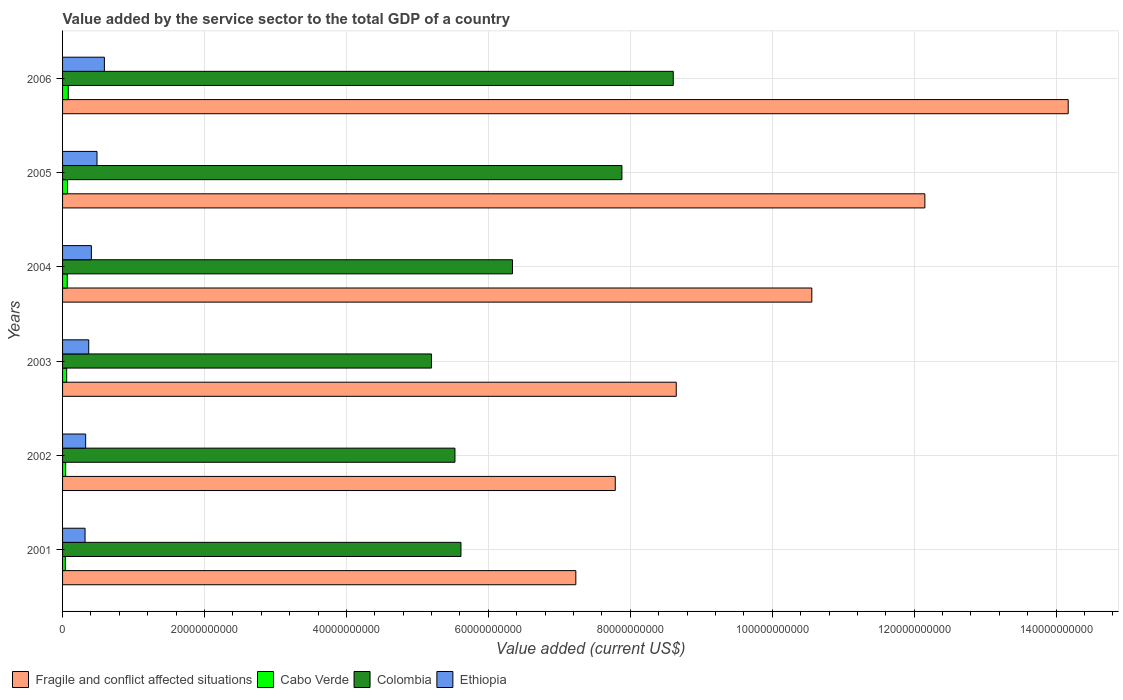Are the number of bars per tick equal to the number of legend labels?
Keep it short and to the point. Yes. Are the number of bars on each tick of the Y-axis equal?
Give a very brief answer. Yes. What is the label of the 2nd group of bars from the top?
Your answer should be very brief. 2005. In how many cases, is the number of bars for a given year not equal to the number of legend labels?
Provide a short and direct response. 0. What is the value added by the service sector to the total GDP in Cabo Verde in 2003?
Offer a very short reply. 5.81e+08. Across all years, what is the maximum value added by the service sector to the total GDP in Cabo Verde?
Your answer should be very brief. 8.04e+08. Across all years, what is the minimum value added by the service sector to the total GDP in Colombia?
Make the answer very short. 5.20e+1. In which year was the value added by the service sector to the total GDP in Colombia minimum?
Ensure brevity in your answer.  2003. What is the total value added by the service sector to the total GDP in Ethiopia in the graph?
Offer a very short reply. 2.49e+1. What is the difference between the value added by the service sector to the total GDP in Fragile and conflict affected situations in 2003 and that in 2004?
Keep it short and to the point. -1.91e+1. What is the difference between the value added by the service sector to the total GDP in Colombia in 2004 and the value added by the service sector to the total GDP in Fragile and conflict affected situations in 2003?
Make the answer very short. -2.31e+1. What is the average value added by the service sector to the total GDP in Colombia per year?
Your answer should be very brief. 6.53e+1. In the year 2001, what is the difference between the value added by the service sector to the total GDP in Fragile and conflict affected situations and value added by the service sector to the total GDP in Colombia?
Make the answer very short. 1.62e+1. What is the ratio of the value added by the service sector to the total GDP in Cabo Verde in 2003 to that in 2005?
Offer a terse response. 0.83. Is the difference between the value added by the service sector to the total GDP in Fragile and conflict affected situations in 2001 and 2005 greater than the difference between the value added by the service sector to the total GDP in Colombia in 2001 and 2005?
Your response must be concise. No. What is the difference between the highest and the second highest value added by the service sector to the total GDP in Ethiopia?
Keep it short and to the point. 1.04e+09. What is the difference between the highest and the lowest value added by the service sector to the total GDP in Ethiopia?
Provide a succinct answer. 2.73e+09. What does the 4th bar from the top in 2001 represents?
Keep it short and to the point. Fragile and conflict affected situations. What does the 4th bar from the bottom in 2001 represents?
Make the answer very short. Ethiopia. How many bars are there?
Offer a terse response. 24. How many years are there in the graph?
Your response must be concise. 6. Are the values on the major ticks of X-axis written in scientific E-notation?
Offer a terse response. No. What is the title of the graph?
Make the answer very short. Value added by the service sector to the total GDP of a country. What is the label or title of the X-axis?
Your answer should be compact. Value added (current US$). What is the Value added (current US$) of Fragile and conflict affected situations in 2001?
Your response must be concise. 7.23e+1. What is the Value added (current US$) of Cabo Verde in 2001?
Your response must be concise. 3.91e+08. What is the Value added (current US$) of Colombia in 2001?
Your response must be concise. 5.61e+1. What is the Value added (current US$) in Ethiopia in 2001?
Keep it short and to the point. 3.17e+09. What is the Value added (current US$) in Fragile and conflict affected situations in 2002?
Give a very brief answer. 7.79e+1. What is the Value added (current US$) of Cabo Verde in 2002?
Your answer should be very brief. 4.38e+08. What is the Value added (current US$) of Colombia in 2002?
Your answer should be very brief. 5.53e+1. What is the Value added (current US$) in Ethiopia in 2002?
Keep it short and to the point. 3.25e+09. What is the Value added (current US$) in Fragile and conflict affected situations in 2003?
Give a very brief answer. 8.65e+1. What is the Value added (current US$) in Cabo Verde in 2003?
Keep it short and to the point. 5.81e+08. What is the Value added (current US$) in Colombia in 2003?
Give a very brief answer. 5.20e+1. What is the Value added (current US$) in Ethiopia in 2003?
Your answer should be very brief. 3.69e+09. What is the Value added (current US$) of Fragile and conflict affected situations in 2004?
Your response must be concise. 1.06e+11. What is the Value added (current US$) of Cabo Verde in 2004?
Your answer should be very brief. 6.65e+08. What is the Value added (current US$) in Colombia in 2004?
Your answer should be very brief. 6.34e+1. What is the Value added (current US$) of Ethiopia in 2004?
Offer a terse response. 4.06e+09. What is the Value added (current US$) in Fragile and conflict affected situations in 2005?
Give a very brief answer. 1.22e+11. What is the Value added (current US$) in Cabo Verde in 2005?
Your answer should be very brief. 6.98e+08. What is the Value added (current US$) of Colombia in 2005?
Ensure brevity in your answer.  7.88e+1. What is the Value added (current US$) of Ethiopia in 2005?
Keep it short and to the point. 4.85e+09. What is the Value added (current US$) in Fragile and conflict affected situations in 2006?
Your response must be concise. 1.42e+11. What is the Value added (current US$) in Cabo Verde in 2006?
Your answer should be very brief. 8.04e+08. What is the Value added (current US$) of Colombia in 2006?
Offer a very short reply. 8.61e+1. What is the Value added (current US$) of Ethiopia in 2006?
Make the answer very short. 5.89e+09. Across all years, what is the maximum Value added (current US$) in Fragile and conflict affected situations?
Ensure brevity in your answer.  1.42e+11. Across all years, what is the maximum Value added (current US$) in Cabo Verde?
Offer a terse response. 8.04e+08. Across all years, what is the maximum Value added (current US$) in Colombia?
Your answer should be very brief. 8.61e+1. Across all years, what is the maximum Value added (current US$) of Ethiopia?
Your response must be concise. 5.89e+09. Across all years, what is the minimum Value added (current US$) in Fragile and conflict affected situations?
Your answer should be very brief. 7.23e+1. Across all years, what is the minimum Value added (current US$) of Cabo Verde?
Offer a very short reply. 3.91e+08. Across all years, what is the minimum Value added (current US$) of Colombia?
Offer a very short reply. 5.20e+1. Across all years, what is the minimum Value added (current US$) in Ethiopia?
Keep it short and to the point. 3.17e+09. What is the total Value added (current US$) of Fragile and conflict affected situations in the graph?
Offer a terse response. 6.05e+11. What is the total Value added (current US$) in Cabo Verde in the graph?
Provide a short and direct response. 3.58e+09. What is the total Value added (current US$) of Colombia in the graph?
Provide a short and direct response. 3.92e+11. What is the total Value added (current US$) in Ethiopia in the graph?
Provide a succinct answer. 2.49e+1. What is the difference between the Value added (current US$) in Fragile and conflict affected situations in 2001 and that in 2002?
Make the answer very short. -5.56e+09. What is the difference between the Value added (current US$) in Cabo Verde in 2001 and that in 2002?
Ensure brevity in your answer.  -4.75e+07. What is the difference between the Value added (current US$) of Colombia in 2001 and that in 2002?
Your answer should be compact. 8.46e+08. What is the difference between the Value added (current US$) of Ethiopia in 2001 and that in 2002?
Your response must be concise. -8.46e+07. What is the difference between the Value added (current US$) of Fragile and conflict affected situations in 2001 and that in 2003?
Ensure brevity in your answer.  -1.41e+1. What is the difference between the Value added (current US$) in Cabo Verde in 2001 and that in 2003?
Your answer should be very brief. -1.90e+08. What is the difference between the Value added (current US$) in Colombia in 2001 and that in 2003?
Keep it short and to the point. 4.15e+09. What is the difference between the Value added (current US$) of Ethiopia in 2001 and that in 2003?
Your answer should be very brief. -5.18e+08. What is the difference between the Value added (current US$) in Fragile and conflict affected situations in 2001 and that in 2004?
Offer a terse response. -3.33e+1. What is the difference between the Value added (current US$) of Cabo Verde in 2001 and that in 2004?
Provide a short and direct response. -2.74e+08. What is the difference between the Value added (current US$) of Colombia in 2001 and that in 2004?
Offer a terse response. -7.26e+09. What is the difference between the Value added (current US$) of Ethiopia in 2001 and that in 2004?
Your response must be concise. -8.91e+08. What is the difference between the Value added (current US$) in Fragile and conflict affected situations in 2001 and that in 2005?
Provide a short and direct response. -4.92e+1. What is the difference between the Value added (current US$) of Cabo Verde in 2001 and that in 2005?
Your answer should be compact. -3.07e+08. What is the difference between the Value added (current US$) in Colombia in 2001 and that in 2005?
Keep it short and to the point. -2.27e+1. What is the difference between the Value added (current US$) in Ethiopia in 2001 and that in 2005?
Make the answer very short. -1.69e+09. What is the difference between the Value added (current US$) of Fragile and conflict affected situations in 2001 and that in 2006?
Offer a very short reply. -6.94e+1. What is the difference between the Value added (current US$) of Cabo Verde in 2001 and that in 2006?
Your answer should be compact. -4.13e+08. What is the difference between the Value added (current US$) of Colombia in 2001 and that in 2006?
Provide a succinct answer. -2.99e+1. What is the difference between the Value added (current US$) in Ethiopia in 2001 and that in 2006?
Ensure brevity in your answer.  -2.73e+09. What is the difference between the Value added (current US$) in Fragile and conflict affected situations in 2002 and that in 2003?
Your response must be concise. -8.59e+09. What is the difference between the Value added (current US$) of Cabo Verde in 2002 and that in 2003?
Make the answer very short. -1.42e+08. What is the difference between the Value added (current US$) in Colombia in 2002 and that in 2003?
Keep it short and to the point. 3.31e+09. What is the difference between the Value added (current US$) of Ethiopia in 2002 and that in 2003?
Ensure brevity in your answer.  -4.33e+08. What is the difference between the Value added (current US$) of Fragile and conflict affected situations in 2002 and that in 2004?
Ensure brevity in your answer.  -2.77e+1. What is the difference between the Value added (current US$) of Cabo Verde in 2002 and that in 2004?
Provide a succinct answer. -2.26e+08. What is the difference between the Value added (current US$) in Colombia in 2002 and that in 2004?
Provide a succinct answer. -8.11e+09. What is the difference between the Value added (current US$) of Ethiopia in 2002 and that in 2004?
Give a very brief answer. -8.06e+08. What is the difference between the Value added (current US$) in Fragile and conflict affected situations in 2002 and that in 2005?
Your response must be concise. -4.36e+1. What is the difference between the Value added (current US$) in Cabo Verde in 2002 and that in 2005?
Your answer should be compact. -2.59e+08. What is the difference between the Value added (current US$) in Colombia in 2002 and that in 2005?
Keep it short and to the point. -2.35e+1. What is the difference between the Value added (current US$) in Ethiopia in 2002 and that in 2005?
Your response must be concise. -1.60e+09. What is the difference between the Value added (current US$) in Fragile and conflict affected situations in 2002 and that in 2006?
Offer a terse response. -6.38e+1. What is the difference between the Value added (current US$) in Cabo Verde in 2002 and that in 2006?
Give a very brief answer. -3.66e+08. What is the difference between the Value added (current US$) in Colombia in 2002 and that in 2006?
Give a very brief answer. -3.08e+1. What is the difference between the Value added (current US$) in Ethiopia in 2002 and that in 2006?
Ensure brevity in your answer.  -2.64e+09. What is the difference between the Value added (current US$) in Fragile and conflict affected situations in 2003 and that in 2004?
Provide a short and direct response. -1.91e+1. What is the difference between the Value added (current US$) in Cabo Verde in 2003 and that in 2004?
Keep it short and to the point. -8.42e+07. What is the difference between the Value added (current US$) in Colombia in 2003 and that in 2004?
Your response must be concise. -1.14e+1. What is the difference between the Value added (current US$) in Ethiopia in 2003 and that in 2004?
Make the answer very short. -3.73e+08. What is the difference between the Value added (current US$) of Fragile and conflict affected situations in 2003 and that in 2005?
Offer a very short reply. -3.50e+1. What is the difference between the Value added (current US$) of Cabo Verde in 2003 and that in 2005?
Ensure brevity in your answer.  -1.17e+08. What is the difference between the Value added (current US$) of Colombia in 2003 and that in 2005?
Make the answer very short. -2.68e+1. What is the difference between the Value added (current US$) of Ethiopia in 2003 and that in 2005?
Ensure brevity in your answer.  -1.17e+09. What is the difference between the Value added (current US$) of Fragile and conflict affected situations in 2003 and that in 2006?
Provide a short and direct response. -5.52e+1. What is the difference between the Value added (current US$) of Cabo Verde in 2003 and that in 2006?
Offer a very short reply. -2.24e+08. What is the difference between the Value added (current US$) of Colombia in 2003 and that in 2006?
Your response must be concise. -3.41e+1. What is the difference between the Value added (current US$) in Ethiopia in 2003 and that in 2006?
Make the answer very short. -2.21e+09. What is the difference between the Value added (current US$) of Fragile and conflict affected situations in 2004 and that in 2005?
Your answer should be compact. -1.59e+1. What is the difference between the Value added (current US$) of Cabo Verde in 2004 and that in 2005?
Provide a succinct answer. -3.30e+07. What is the difference between the Value added (current US$) in Colombia in 2004 and that in 2005?
Your answer should be very brief. -1.54e+1. What is the difference between the Value added (current US$) in Ethiopia in 2004 and that in 2005?
Provide a succinct answer. -7.94e+08. What is the difference between the Value added (current US$) in Fragile and conflict affected situations in 2004 and that in 2006?
Ensure brevity in your answer.  -3.61e+1. What is the difference between the Value added (current US$) in Cabo Verde in 2004 and that in 2006?
Make the answer very short. -1.39e+08. What is the difference between the Value added (current US$) of Colombia in 2004 and that in 2006?
Provide a short and direct response. -2.27e+1. What is the difference between the Value added (current US$) in Ethiopia in 2004 and that in 2006?
Give a very brief answer. -1.83e+09. What is the difference between the Value added (current US$) of Fragile and conflict affected situations in 2005 and that in 2006?
Offer a terse response. -2.02e+1. What is the difference between the Value added (current US$) of Cabo Verde in 2005 and that in 2006?
Offer a very short reply. -1.06e+08. What is the difference between the Value added (current US$) in Colombia in 2005 and that in 2006?
Your answer should be compact. -7.23e+09. What is the difference between the Value added (current US$) of Ethiopia in 2005 and that in 2006?
Offer a terse response. -1.04e+09. What is the difference between the Value added (current US$) of Fragile and conflict affected situations in 2001 and the Value added (current US$) of Cabo Verde in 2002?
Ensure brevity in your answer.  7.19e+1. What is the difference between the Value added (current US$) in Fragile and conflict affected situations in 2001 and the Value added (current US$) in Colombia in 2002?
Your answer should be compact. 1.70e+1. What is the difference between the Value added (current US$) in Fragile and conflict affected situations in 2001 and the Value added (current US$) in Ethiopia in 2002?
Your answer should be compact. 6.91e+1. What is the difference between the Value added (current US$) in Cabo Verde in 2001 and the Value added (current US$) in Colombia in 2002?
Ensure brevity in your answer.  -5.49e+1. What is the difference between the Value added (current US$) of Cabo Verde in 2001 and the Value added (current US$) of Ethiopia in 2002?
Offer a terse response. -2.86e+09. What is the difference between the Value added (current US$) in Colombia in 2001 and the Value added (current US$) in Ethiopia in 2002?
Your answer should be very brief. 5.29e+1. What is the difference between the Value added (current US$) in Fragile and conflict affected situations in 2001 and the Value added (current US$) in Cabo Verde in 2003?
Your response must be concise. 7.17e+1. What is the difference between the Value added (current US$) in Fragile and conflict affected situations in 2001 and the Value added (current US$) in Colombia in 2003?
Keep it short and to the point. 2.03e+1. What is the difference between the Value added (current US$) in Fragile and conflict affected situations in 2001 and the Value added (current US$) in Ethiopia in 2003?
Your answer should be very brief. 6.86e+1. What is the difference between the Value added (current US$) of Cabo Verde in 2001 and the Value added (current US$) of Colombia in 2003?
Ensure brevity in your answer.  -5.16e+1. What is the difference between the Value added (current US$) of Cabo Verde in 2001 and the Value added (current US$) of Ethiopia in 2003?
Provide a short and direct response. -3.30e+09. What is the difference between the Value added (current US$) of Colombia in 2001 and the Value added (current US$) of Ethiopia in 2003?
Provide a short and direct response. 5.25e+1. What is the difference between the Value added (current US$) of Fragile and conflict affected situations in 2001 and the Value added (current US$) of Cabo Verde in 2004?
Your answer should be very brief. 7.17e+1. What is the difference between the Value added (current US$) in Fragile and conflict affected situations in 2001 and the Value added (current US$) in Colombia in 2004?
Your answer should be very brief. 8.93e+09. What is the difference between the Value added (current US$) of Fragile and conflict affected situations in 2001 and the Value added (current US$) of Ethiopia in 2004?
Keep it short and to the point. 6.83e+1. What is the difference between the Value added (current US$) in Cabo Verde in 2001 and the Value added (current US$) in Colombia in 2004?
Give a very brief answer. -6.30e+1. What is the difference between the Value added (current US$) in Cabo Verde in 2001 and the Value added (current US$) in Ethiopia in 2004?
Give a very brief answer. -3.67e+09. What is the difference between the Value added (current US$) of Colombia in 2001 and the Value added (current US$) of Ethiopia in 2004?
Provide a short and direct response. 5.21e+1. What is the difference between the Value added (current US$) in Fragile and conflict affected situations in 2001 and the Value added (current US$) in Cabo Verde in 2005?
Keep it short and to the point. 7.16e+1. What is the difference between the Value added (current US$) of Fragile and conflict affected situations in 2001 and the Value added (current US$) of Colombia in 2005?
Your response must be concise. -6.49e+09. What is the difference between the Value added (current US$) in Fragile and conflict affected situations in 2001 and the Value added (current US$) in Ethiopia in 2005?
Your answer should be compact. 6.75e+1. What is the difference between the Value added (current US$) in Cabo Verde in 2001 and the Value added (current US$) in Colombia in 2005?
Provide a succinct answer. -7.84e+1. What is the difference between the Value added (current US$) in Cabo Verde in 2001 and the Value added (current US$) in Ethiopia in 2005?
Offer a very short reply. -4.46e+09. What is the difference between the Value added (current US$) of Colombia in 2001 and the Value added (current US$) of Ethiopia in 2005?
Your answer should be compact. 5.13e+1. What is the difference between the Value added (current US$) in Fragile and conflict affected situations in 2001 and the Value added (current US$) in Cabo Verde in 2006?
Give a very brief answer. 7.15e+1. What is the difference between the Value added (current US$) in Fragile and conflict affected situations in 2001 and the Value added (current US$) in Colombia in 2006?
Provide a succinct answer. -1.37e+1. What is the difference between the Value added (current US$) of Fragile and conflict affected situations in 2001 and the Value added (current US$) of Ethiopia in 2006?
Provide a succinct answer. 6.64e+1. What is the difference between the Value added (current US$) in Cabo Verde in 2001 and the Value added (current US$) in Colombia in 2006?
Provide a short and direct response. -8.57e+1. What is the difference between the Value added (current US$) of Cabo Verde in 2001 and the Value added (current US$) of Ethiopia in 2006?
Give a very brief answer. -5.50e+09. What is the difference between the Value added (current US$) of Colombia in 2001 and the Value added (current US$) of Ethiopia in 2006?
Offer a terse response. 5.02e+1. What is the difference between the Value added (current US$) in Fragile and conflict affected situations in 2002 and the Value added (current US$) in Cabo Verde in 2003?
Offer a terse response. 7.73e+1. What is the difference between the Value added (current US$) in Fragile and conflict affected situations in 2002 and the Value added (current US$) in Colombia in 2003?
Your answer should be very brief. 2.59e+1. What is the difference between the Value added (current US$) of Fragile and conflict affected situations in 2002 and the Value added (current US$) of Ethiopia in 2003?
Offer a terse response. 7.42e+1. What is the difference between the Value added (current US$) in Cabo Verde in 2002 and the Value added (current US$) in Colombia in 2003?
Offer a very short reply. -5.15e+1. What is the difference between the Value added (current US$) in Cabo Verde in 2002 and the Value added (current US$) in Ethiopia in 2003?
Make the answer very short. -3.25e+09. What is the difference between the Value added (current US$) of Colombia in 2002 and the Value added (current US$) of Ethiopia in 2003?
Make the answer very short. 5.16e+1. What is the difference between the Value added (current US$) in Fragile and conflict affected situations in 2002 and the Value added (current US$) in Cabo Verde in 2004?
Your answer should be very brief. 7.72e+1. What is the difference between the Value added (current US$) in Fragile and conflict affected situations in 2002 and the Value added (current US$) in Colombia in 2004?
Offer a terse response. 1.45e+1. What is the difference between the Value added (current US$) of Fragile and conflict affected situations in 2002 and the Value added (current US$) of Ethiopia in 2004?
Keep it short and to the point. 7.38e+1. What is the difference between the Value added (current US$) of Cabo Verde in 2002 and the Value added (current US$) of Colombia in 2004?
Make the answer very short. -6.30e+1. What is the difference between the Value added (current US$) in Cabo Verde in 2002 and the Value added (current US$) in Ethiopia in 2004?
Offer a very short reply. -3.62e+09. What is the difference between the Value added (current US$) of Colombia in 2002 and the Value added (current US$) of Ethiopia in 2004?
Make the answer very short. 5.12e+1. What is the difference between the Value added (current US$) in Fragile and conflict affected situations in 2002 and the Value added (current US$) in Cabo Verde in 2005?
Your answer should be very brief. 7.72e+1. What is the difference between the Value added (current US$) of Fragile and conflict affected situations in 2002 and the Value added (current US$) of Colombia in 2005?
Offer a terse response. -9.39e+08. What is the difference between the Value added (current US$) in Fragile and conflict affected situations in 2002 and the Value added (current US$) in Ethiopia in 2005?
Make the answer very short. 7.30e+1. What is the difference between the Value added (current US$) of Cabo Verde in 2002 and the Value added (current US$) of Colombia in 2005?
Offer a terse response. -7.84e+1. What is the difference between the Value added (current US$) in Cabo Verde in 2002 and the Value added (current US$) in Ethiopia in 2005?
Offer a very short reply. -4.42e+09. What is the difference between the Value added (current US$) of Colombia in 2002 and the Value added (current US$) of Ethiopia in 2005?
Offer a terse response. 5.04e+1. What is the difference between the Value added (current US$) of Fragile and conflict affected situations in 2002 and the Value added (current US$) of Cabo Verde in 2006?
Offer a terse response. 7.71e+1. What is the difference between the Value added (current US$) of Fragile and conflict affected situations in 2002 and the Value added (current US$) of Colombia in 2006?
Your response must be concise. -8.17e+09. What is the difference between the Value added (current US$) in Fragile and conflict affected situations in 2002 and the Value added (current US$) in Ethiopia in 2006?
Offer a terse response. 7.20e+1. What is the difference between the Value added (current US$) of Cabo Verde in 2002 and the Value added (current US$) of Colombia in 2006?
Ensure brevity in your answer.  -8.56e+1. What is the difference between the Value added (current US$) in Cabo Verde in 2002 and the Value added (current US$) in Ethiopia in 2006?
Make the answer very short. -5.46e+09. What is the difference between the Value added (current US$) of Colombia in 2002 and the Value added (current US$) of Ethiopia in 2006?
Keep it short and to the point. 4.94e+1. What is the difference between the Value added (current US$) of Fragile and conflict affected situations in 2003 and the Value added (current US$) of Cabo Verde in 2004?
Ensure brevity in your answer.  8.58e+1. What is the difference between the Value added (current US$) of Fragile and conflict affected situations in 2003 and the Value added (current US$) of Colombia in 2004?
Your answer should be compact. 2.31e+1. What is the difference between the Value added (current US$) of Fragile and conflict affected situations in 2003 and the Value added (current US$) of Ethiopia in 2004?
Offer a very short reply. 8.24e+1. What is the difference between the Value added (current US$) of Cabo Verde in 2003 and the Value added (current US$) of Colombia in 2004?
Ensure brevity in your answer.  -6.28e+1. What is the difference between the Value added (current US$) in Cabo Verde in 2003 and the Value added (current US$) in Ethiopia in 2004?
Make the answer very short. -3.48e+09. What is the difference between the Value added (current US$) in Colombia in 2003 and the Value added (current US$) in Ethiopia in 2004?
Keep it short and to the point. 4.79e+1. What is the difference between the Value added (current US$) of Fragile and conflict affected situations in 2003 and the Value added (current US$) of Cabo Verde in 2005?
Offer a terse response. 8.58e+1. What is the difference between the Value added (current US$) in Fragile and conflict affected situations in 2003 and the Value added (current US$) in Colombia in 2005?
Give a very brief answer. 7.65e+09. What is the difference between the Value added (current US$) in Fragile and conflict affected situations in 2003 and the Value added (current US$) in Ethiopia in 2005?
Keep it short and to the point. 8.16e+1. What is the difference between the Value added (current US$) of Cabo Verde in 2003 and the Value added (current US$) of Colombia in 2005?
Ensure brevity in your answer.  -7.82e+1. What is the difference between the Value added (current US$) in Cabo Verde in 2003 and the Value added (current US$) in Ethiopia in 2005?
Make the answer very short. -4.27e+09. What is the difference between the Value added (current US$) of Colombia in 2003 and the Value added (current US$) of Ethiopia in 2005?
Your answer should be very brief. 4.71e+1. What is the difference between the Value added (current US$) of Fragile and conflict affected situations in 2003 and the Value added (current US$) of Cabo Verde in 2006?
Make the answer very short. 8.57e+1. What is the difference between the Value added (current US$) of Fragile and conflict affected situations in 2003 and the Value added (current US$) of Colombia in 2006?
Give a very brief answer. 4.20e+08. What is the difference between the Value added (current US$) in Fragile and conflict affected situations in 2003 and the Value added (current US$) in Ethiopia in 2006?
Provide a succinct answer. 8.06e+1. What is the difference between the Value added (current US$) in Cabo Verde in 2003 and the Value added (current US$) in Colombia in 2006?
Provide a short and direct response. -8.55e+1. What is the difference between the Value added (current US$) of Cabo Verde in 2003 and the Value added (current US$) of Ethiopia in 2006?
Give a very brief answer. -5.31e+09. What is the difference between the Value added (current US$) in Colombia in 2003 and the Value added (current US$) in Ethiopia in 2006?
Give a very brief answer. 4.61e+1. What is the difference between the Value added (current US$) of Fragile and conflict affected situations in 2004 and the Value added (current US$) of Cabo Verde in 2005?
Provide a succinct answer. 1.05e+11. What is the difference between the Value added (current US$) of Fragile and conflict affected situations in 2004 and the Value added (current US$) of Colombia in 2005?
Provide a short and direct response. 2.68e+1. What is the difference between the Value added (current US$) in Fragile and conflict affected situations in 2004 and the Value added (current US$) in Ethiopia in 2005?
Give a very brief answer. 1.01e+11. What is the difference between the Value added (current US$) in Cabo Verde in 2004 and the Value added (current US$) in Colombia in 2005?
Provide a succinct answer. -7.82e+1. What is the difference between the Value added (current US$) of Cabo Verde in 2004 and the Value added (current US$) of Ethiopia in 2005?
Your response must be concise. -4.19e+09. What is the difference between the Value added (current US$) of Colombia in 2004 and the Value added (current US$) of Ethiopia in 2005?
Provide a succinct answer. 5.85e+1. What is the difference between the Value added (current US$) of Fragile and conflict affected situations in 2004 and the Value added (current US$) of Cabo Verde in 2006?
Provide a short and direct response. 1.05e+11. What is the difference between the Value added (current US$) of Fragile and conflict affected situations in 2004 and the Value added (current US$) of Colombia in 2006?
Your answer should be very brief. 1.95e+1. What is the difference between the Value added (current US$) of Fragile and conflict affected situations in 2004 and the Value added (current US$) of Ethiopia in 2006?
Offer a terse response. 9.97e+1. What is the difference between the Value added (current US$) in Cabo Verde in 2004 and the Value added (current US$) in Colombia in 2006?
Offer a very short reply. -8.54e+1. What is the difference between the Value added (current US$) in Cabo Verde in 2004 and the Value added (current US$) in Ethiopia in 2006?
Your response must be concise. -5.23e+09. What is the difference between the Value added (current US$) of Colombia in 2004 and the Value added (current US$) of Ethiopia in 2006?
Provide a succinct answer. 5.75e+1. What is the difference between the Value added (current US$) in Fragile and conflict affected situations in 2005 and the Value added (current US$) in Cabo Verde in 2006?
Your answer should be compact. 1.21e+11. What is the difference between the Value added (current US$) of Fragile and conflict affected situations in 2005 and the Value added (current US$) of Colombia in 2006?
Offer a very short reply. 3.55e+1. What is the difference between the Value added (current US$) of Fragile and conflict affected situations in 2005 and the Value added (current US$) of Ethiopia in 2006?
Keep it short and to the point. 1.16e+11. What is the difference between the Value added (current US$) in Cabo Verde in 2005 and the Value added (current US$) in Colombia in 2006?
Offer a very short reply. -8.54e+1. What is the difference between the Value added (current US$) of Cabo Verde in 2005 and the Value added (current US$) of Ethiopia in 2006?
Give a very brief answer. -5.20e+09. What is the difference between the Value added (current US$) of Colombia in 2005 and the Value added (current US$) of Ethiopia in 2006?
Keep it short and to the point. 7.29e+1. What is the average Value added (current US$) in Fragile and conflict affected situations per year?
Your answer should be very brief. 1.01e+11. What is the average Value added (current US$) in Cabo Verde per year?
Your response must be concise. 5.96e+08. What is the average Value added (current US$) in Colombia per year?
Your answer should be very brief. 6.53e+1. What is the average Value added (current US$) of Ethiopia per year?
Offer a very short reply. 4.15e+09. In the year 2001, what is the difference between the Value added (current US$) of Fragile and conflict affected situations and Value added (current US$) of Cabo Verde?
Keep it short and to the point. 7.19e+1. In the year 2001, what is the difference between the Value added (current US$) of Fragile and conflict affected situations and Value added (current US$) of Colombia?
Make the answer very short. 1.62e+1. In the year 2001, what is the difference between the Value added (current US$) of Fragile and conflict affected situations and Value added (current US$) of Ethiopia?
Your answer should be very brief. 6.92e+1. In the year 2001, what is the difference between the Value added (current US$) in Cabo Verde and Value added (current US$) in Colombia?
Make the answer very short. -5.57e+1. In the year 2001, what is the difference between the Value added (current US$) in Cabo Verde and Value added (current US$) in Ethiopia?
Give a very brief answer. -2.78e+09. In the year 2001, what is the difference between the Value added (current US$) of Colombia and Value added (current US$) of Ethiopia?
Provide a succinct answer. 5.30e+1. In the year 2002, what is the difference between the Value added (current US$) in Fragile and conflict affected situations and Value added (current US$) in Cabo Verde?
Provide a short and direct response. 7.74e+1. In the year 2002, what is the difference between the Value added (current US$) of Fragile and conflict affected situations and Value added (current US$) of Colombia?
Give a very brief answer. 2.26e+1. In the year 2002, what is the difference between the Value added (current US$) in Fragile and conflict affected situations and Value added (current US$) in Ethiopia?
Provide a succinct answer. 7.46e+1. In the year 2002, what is the difference between the Value added (current US$) of Cabo Verde and Value added (current US$) of Colombia?
Provide a succinct answer. -5.49e+1. In the year 2002, what is the difference between the Value added (current US$) in Cabo Verde and Value added (current US$) in Ethiopia?
Offer a terse response. -2.82e+09. In the year 2002, what is the difference between the Value added (current US$) in Colombia and Value added (current US$) in Ethiopia?
Offer a very short reply. 5.20e+1. In the year 2003, what is the difference between the Value added (current US$) of Fragile and conflict affected situations and Value added (current US$) of Cabo Verde?
Make the answer very short. 8.59e+1. In the year 2003, what is the difference between the Value added (current US$) of Fragile and conflict affected situations and Value added (current US$) of Colombia?
Offer a very short reply. 3.45e+1. In the year 2003, what is the difference between the Value added (current US$) of Fragile and conflict affected situations and Value added (current US$) of Ethiopia?
Provide a short and direct response. 8.28e+1. In the year 2003, what is the difference between the Value added (current US$) in Cabo Verde and Value added (current US$) in Colombia?
Your response must be concise. -5.14e+1. In the year 2003, what is the difference between the Value added (current US$) of Cabo Verde and Value added (current US$) of Ethiopia?
Your response must be concise. -3.11e+09. In the year 2003, what is the difference between the Value added (current US$) in Colombia and Value added (current US$) in Ethiopia?
Provide a succinct answer. 4.83e+1. In the year 2004, what is the difference between the Value added (current US$) in Fragile and conflict affected situations and Value added (current US$) in Cabo Verde?
Your answer should be very brief. 1.05e+11. In the year 2004, what is the difference between the Value added (current US$) of Fragile and conflict affected situations and Value added (current US$) of Colombia?
Ensure brevity in your answer.  4.22e+1. In the year 2004, what is the difference between the Value added (current US$) in Fragile and conflict affected situations and Value added (current US$) in Ethiopia?
Offer a terse response. 1.02e+11. In the year 2004, what is the difference between the Value added (current US$) of Cabo Verde and Value added (current US$) of Colombia?
Make the answer very short. -6.27e+1. In the year 2004, what is the difference between the Value added (current US$) of Cabo Verde and Value added (current US$) of Ethiopia?
Make the answer very short. -3.40e+09. In the year 2004, what is the difference between the Value added (current US$) of Colombia and Value added (current US$) of Ethiopia?
Offer a terse response. 5.93e+1. In the year 2005, what is the difference between the Value added (current US$) in Fragile and conflict affected situations and Value added (current US$) in Cabo Verde?
Make the answer very short. 1.21e+11. In the year 2005, what is the difference between the Value added (current US$) in Fragile and conflict affected situations and Value added (current US$) in Colombia?
Keep it short and to the point. 4.27e+1. In the year 2005, what is the difference between the Value added (current US$) in Fragile and conflict affected situations and Value added (current US$) in Ethiopia?
Give a very brief answer. 1.17e+11. In the year 2005, what is the difference between the Value added (current US$) in Cabo Verde and Value added (current US$) in Colombia?
Provide a succinct answer. -7.81e+1. In the year 2005, what is the difference between the Value added (current US$) in Cabo Verde and Value added (current US$) in Ethiopia?
Make the answer very short. -4.16e+09. In the year 2005, what is the difference between the Value added (current US$) in Colombia and Value added (current US$) in Ethiopia?
Give a very brief answer. 7.40e+1. In the year 2006, what is the difference between the Value added (current US$) of Fragile and conflict affected situations and Value added (current US$) of Cabo Verde?
Provide a succinct answer. 1.41e+11. In the year 2006, what is the difference between the Value added (current US$) in Fragile and conflict affected situations and Value added (current US$) in Colombia?
Provide a succinct answer. 5.57e+1. In the year 2006, what is the difference between the Value added (current US$) of Fragile and conflict affected situations and Value added (current US$) of Ethiopia?
Offer a terse response. 1.36e+11. In the year 2006, what is the difference between the Value added (current US$) in Cabo Verde and Value added (current US$) in Colombia?
Your answer should be very brief. -8.52e+1. In the year 2006, what is the difference between the Value added (current US$) in Cabo Verde and Value added (current US$) in Ethiopia?
Make the answer very short. -5.09e+09. In the year 2006, what is the difference between the Value added (current US$) of Colombia and Value added (current US$) of Ethiopia?
Your answer should be very brief. 8.02e+1. What is the ratio of the Value added (current US$) of Fragile and conflict affected situations in 2001 to that in 2002?
Your answer should be very brief. 0.93. What is the ratio of the Value added (current US$) of Cabo Verde in 2001 to that in 2002?
Give a very brief answer. 0.89. What is the ratio of the Value added (current US$) in Colombia in 2001 to that in 2002?
Make the answer very short. 1.02. What is the ratio of the Value added (current US$) of Ethiopia in 2001 to that in 2002?
Provide a short and direct response. 0.97. What is the ratio of the Value added (current US$) of Fragile and conflict affected situations in 2001 to that in 2003?
Offer a very short reply. 0.84. What is the ratio of the Value added (current US$) in Cabo Verde in 2001 to that in 2003?
Your answer should be very brief. 0.67. What is the ratio of the Value added (current US$) in Colombia in 2001 to that in 2003?
Give a very brief answer. 1.08. What is the ratio of the Value added (current US$) in Ethiopia in 2001 to that in 2003?
Keep it short and to the point. 0.86. What is the ratio of the Value added (current US$) of Fragile and conflict affected situations in 2001 to that in 2004?
Offer a terse response. 0.69. What is the ratio of the Value added (current US$) in Cabo Verde in 2001 to that in 2004?
Provide a short and direct response. 0.59. What is the ratio of the Value added (current US$) in Colombia in 2001 to that in 2004?
Provide a succinct answer. 0.89. What is the ratio of the Value added (current US$) of Ethiopia in 2001 to that in 2004?
Your answer should be compact. 0.78. What is the ratio of the Value added (current US$) in Fragile and conflict affected situations in 2001 to that in 2005?
Give a very brief answer. 0.6. What is the ratio of the Value added (current US$) of Cabo Verde in 2001 to that in 2005?
Offer a terse response. 0.56. What is the ratio of the Value added (current US$) in Colombia in 2001 to that in 2005?
Give a very brief answer. 0.71. What is the ratio of the Value added (current US$) of Ethiopia in 2001 to that in 2005?
Provide a short and direct response. 0.65. What is the ratio of the Value added (current US$) of Fragile and conflict affected situations in 2001 to that in 2006?
Provide a short and direct response. 0.51. What is the ratio of the Value added (current US$) in Cabo Verde in 2001 to that in 2006?
Your response must be concise. 0.49. What is the ratio of the Value added (current US$) in Colombia in 2001 to that in 2006?
Give a very brief answer. 0.65. What is the ratio of the Value added (current US$) in Ethiopia in 2001 to that in 2006?
Offer a terse response. 0.54. What is the ratio of the Value added (current US$) in Fragile and conflict affected situations in 2002 to that in 2003?
Your response must be concise. 0.9. What is the ratio of the Value added (current US$) in Cabo Verde in 2002 to that in 2003?
Your answer should be very brief. 0.76. What is the ratio of the Value added (current US$) of Colombia in 2002 to that in 2003?
Provide a short and direct response. 1.06. What is the ratio of the Value added (current US$) in Ethiopia in 2002 to that in 2003?
Your response must be concise. 0.88. What is the ratio of the Value added (current US$) of Fragile and conflict affected situations in 2002 to that in 2004?
Keep it short and to the point. 0.74. What is the ratio of the Value added (current US$) in Cabo Verde in 2002 to that in 2004?
Provide a short and direct response. 0.66. What is the ratio of the Value added (current US$) of Colombia in 2002 to that in 2004?
Give a very brief answer. 0.87. What is the ratio of the Value added (current US$) in Ethiopia in 2002 to that in 2004?
Your response must be concise. 0.8. What is the ratio of the Value added (current US$) of Fragile and conflict affected situations in 2002 to that in 2005?
Offer a very short reply. 0.64. What is the ratio of the Value added (current US$) in Cabo Verde in 2002 to that in 2005?
Your answer should be compact. 0.63. What is the ratio of the Value added (current US$) of Colombia in 2002 to that in 2005?
Provide a succinct answer. 0.7. What is the ratio of the Value added (current US$) in Ethiopia in 2002 to that in 2005?
Your response must be concise. 0.67. What is the ratio of the Value added (current US$) of Fragile and conflict affected situations in 2002 to that in 2006?
Make the answer very short. 0.55. What is the ratio of the Value added (current US$) in Cabo Verde in 2002 to that in 2006?
Your response must be concise. 0.55. What is the ratio of the Value added (current US$) in Colombia in 2002 to that in 2006?
Offer a very short reply. 0.64. What is the ratio of the Value added (current US$) in Ethiopia in 2002 to that in 2006?
Provide a short and direct response. 0.55. What is the ratio of the Value added (current US$) in Fragile and conflict affected situations in 2003 to that in 2004?
Your answer should be very brief. 0.82. What is the ratio of the Value added (current US$) in Cabo Verde in 2003 to that in 2004?
Offer a very short reply. 0.87. What is the ratio of the Value added (current US$) of Colombia in 2003 to that in 2004?
Your answer should be very brief. 0.82. What is the ratio of the Value added (current US$) of Ethiopia in 2003 to that in 2004?
Offer a very short reply. 0.91. What is the ratio of the Value added (current US$) of Fragile and conflict affected situations in 2003 to that in 2005?
Keep it short and to the point. 0.71. What is the ratio of the Value added (current US$) of Cabo Verde in 2003 to that in 2005?
Provide a succinct answer. 0.83. What is the ratio of the Value added (current US$) in Colombia in 2003 to that in 2005?
Offer a very short reply. 0.66. What is the ratio of the Value added (current US$) in Ethiopia in 2003 to that in 2005?
Provide a succinct answer. 0.76. What is the ratio of the Value added (current US$) in Fragile and conflict affected situations in 2003 to that in 2006?
Make the answer very short. 0.61. What is the ratio of the Value added (current US$) in Cabo Verde in 2003 to that in 2006?
Ensure brevity in your answer.  0.72. What is the ratio of the Value added (current US$) of Colombia in 2003 to that in 2006?
Provide a succinct answer. 0.6. What is the ratio of the Value added (current US$) in Ethiopia in 2003 to that in 2006?
Offer a very short reply. 0.63. What is the ratio of the Value added (current US$) of Fragile and conflict affected situations in 2004 to that in 2005?
Your answer should be very brief. 0.87. What is the ratio of the Value added (current US$) in Cabo Verde in 2004 to that in 2005?
Your answer should be very brief. 0.95. What is the ratio of the Value added (current US$) of Colombia in 2004 to that in 2005?
Offer a very short reply. 0.8. What is the ratio of the Value added (current US$) in Ethiopia in 2004 to that in 2005?
Offer a very short reply. 0.84. What is the ratio of the Value added (current US$) of Fragile and conflict affected situations in 2004 to that in 2006?
Keep it short and to the point. 0.74. What is the ratio of the Value added (current US$) in Cabo Verde in 2004 to that in 2006?
Ensure brevity in your answer.  0.83. What is the ratio of the Value added (current US$) in Colombia in 2004 to that in 2006?
Offer a terse response. 0.74. What is the ratio of the Value added (current US$) in Ethiopia in 2004 to that in 2006?
Offer a very short reply. 0.69. What is the ratio of the Value added (current US$) in Fragile and conflict affected situations in 2005 to that in 2006?
Your answer should be very brief. 0.86. What is the ratio of the Value added (current US$) in Cabo Verde in 2005 to that in 2006?
Ensure brevity in your answer.  0.87. What is the ratio of the Value added (current US$) in Colombia in 2005 to that in 2006?
Keep it short and to the point. 0.92. What is the ratio of the Value added (current US$) in Ethiopia in 2005 to that in 2006?
Offer a very short reply. 0.82. What is the difference between the highest and the second highest Value added (current US$) of Fragile and conflict affected situations?
Offer a very short reply. 2.02e+1. What is the difference between the highest and the second highest Value added (current US$) of Cabo Verde?
Offer a terse response. 1.06e+08. What is the difference between the highest and the second highest Value added (current US$) of Colombia?
Give a very brief answer. 7.23e+09. What is the difference between the highest and the second highest Value added (current US$) of Ethiopia?
Make the answer very short. 1.04e+09. What is the difference between the highest and the lowest Value added (current US$) of Fragile and conflict affected situations?
Provide a short and direct response. 6.94e+1. What is the difference between the highest and the lowest Value added (current US$) in Cabo Verde?
Provide a succinct answer. 4.13e+08. What is the difference between the highest and the lowest Value added (current US$) of Colombia?
Keep it short and to the point. 3.41e+1. What is the difference between the highest and the lowest Value added (current US$) in Ethiopia?
Offer a very short reply. 2.73e+09. 